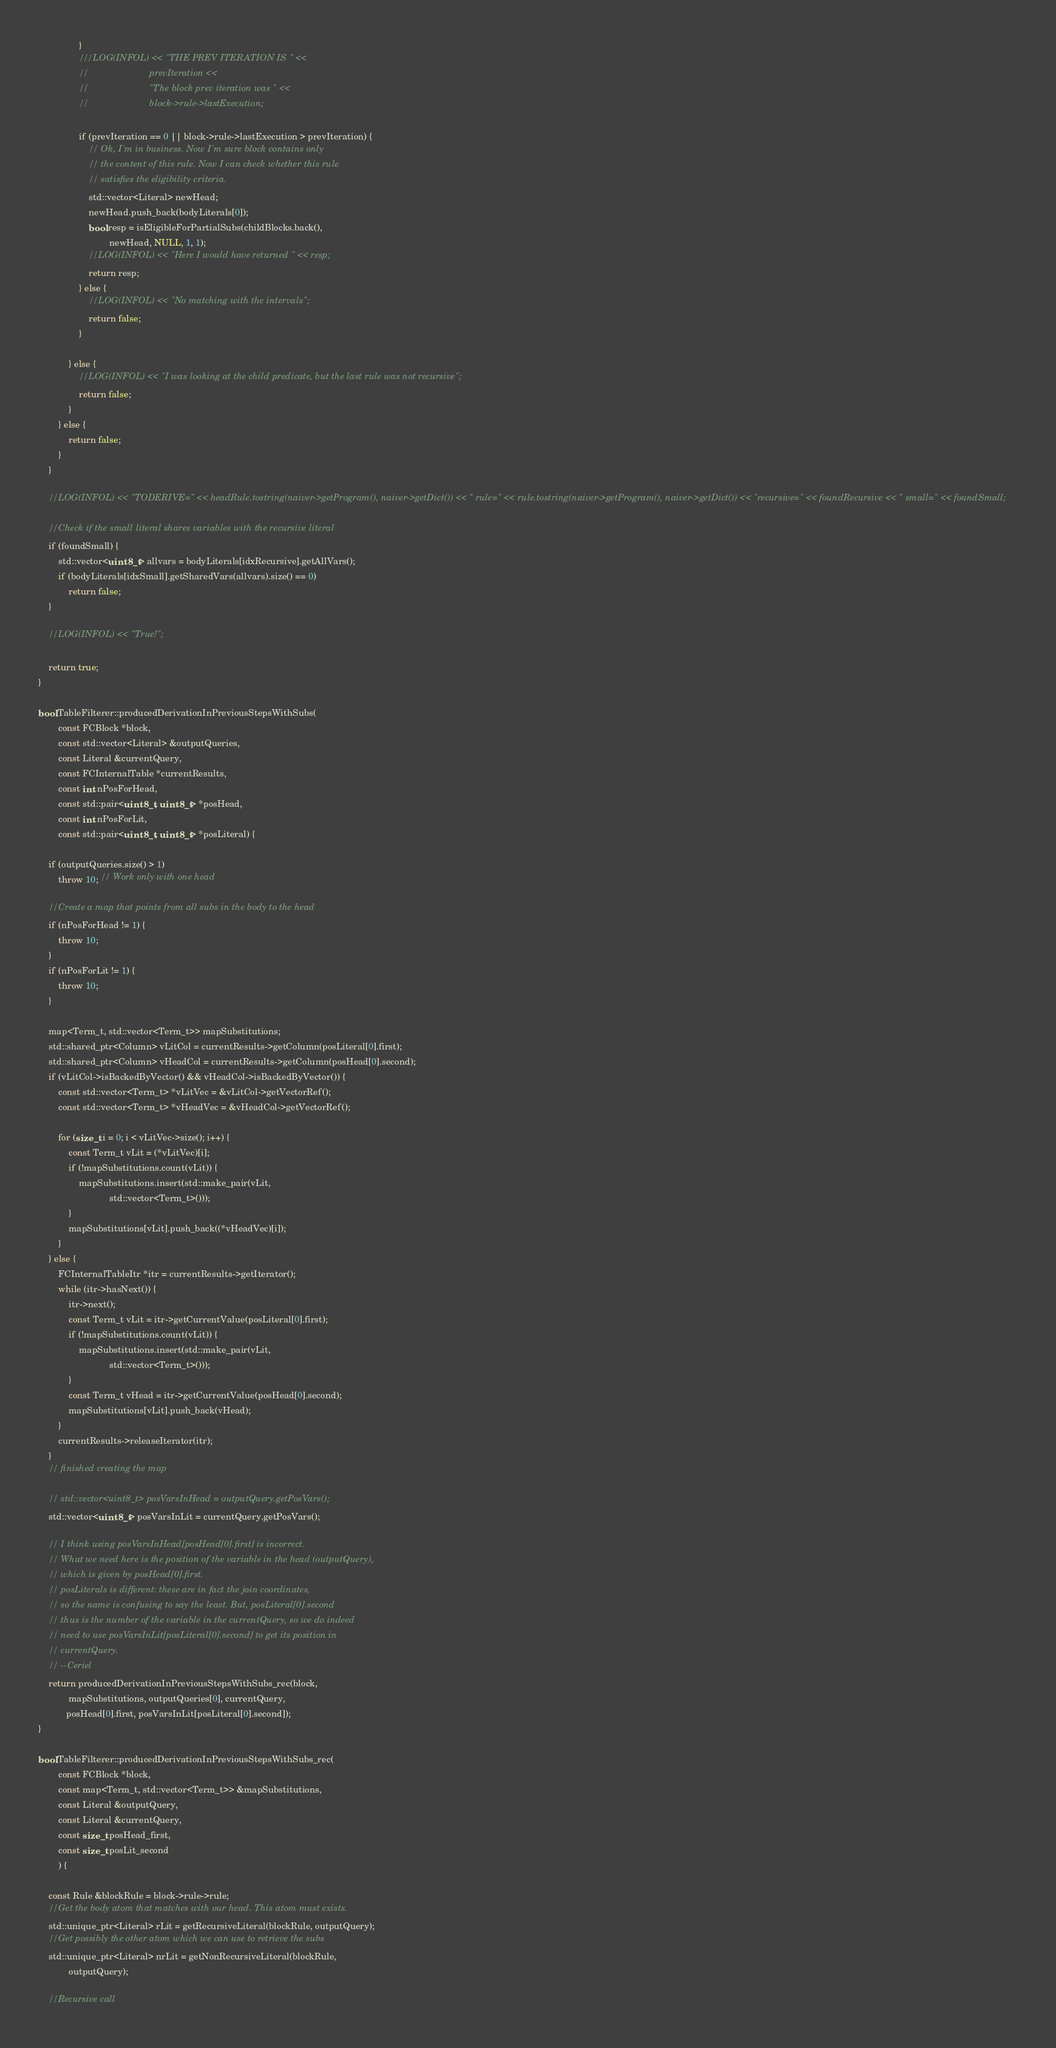<code> <loc_0><loc_0><loc_500><loc_500><_C++_>                }
                ///LOG(INFOL) << "THE PREV ITERATION IS " <<
                //                        prevIteration <<
                //                        "The block prev iteration was " <<
                //                        block->rule->lastExecution;

                if (prevIteration == 0 || block->rule->lastExecution > prevIteration) {
                    // Ok, I'm in business. Now I'm sure block contains only
                    // the content of this rule. Now I can check whether this rule
                    // satisfies the eligibility criteria.
                    std::vector<Literal> newHead;
                    newHead.push_back(bodyLiterals[0]);
                    bool resp = isEligibleForPartialSubs(childBlocks.back(),
                            newHead, NULL, 1, 1);
                    //LOG(INFOL) << "Here I would have returned " << resp;
                    return resp;
                } else {
                    //LOG(INFOL) << "No matching with the intervals";
                    return false;
                }

            } else {
                //LOG(INFOL) << "I was looking at the child predicate, but the last rule was not recursive";
                return false;
            }
        } else {
            return false;
        }
    }

    //LOG(INFOL) << "TODERIVE=" << headRule.tostring(naiver->getProgram(), naiver->getDict()) << " rule=" << rule.tostring(naiver->getProgram(), naiver->getDict()) << "recursive=" << foundRecursive << " small=" << foundSmall;

    //Check if the small literal shares variables with the recursive literal
    if (foundSmall) {
        std::vector<uint8_t> allvars = bodyLiterals[idxRecursive].getAllVars();
        if (bodyLiterals[idxSmall].getSharedVars(allvars).size() == 0)
            return false;
    }

    //LOG(INFOL) << "True!";

    return true;
}

bool TableFilterer::producedDerivationInPreviousStepsWithSubs(
        const FCBlock *block,
        const std::vector<Literal> &outputQueries,
        const Literal &currentQuery,
        const FCInternalTable *currentResults,
        const int nPosForHead,
        const std::pair<uint8_t, uint8_t> *posHead,
        const int nPosForLit,
        const std::pair<uint8_t, uint8_t> *posLiteral) {

    if (outputQueries.size() > 1)
        throw 10; // Work only with one head

    //Create a map that points from all subs in the body to the head
    if (nPosForHead != 1) {
        throw 10;
    }
    if (nPosForLit != 1) {
        throw 10;
    }

    map<Term_t, std::vector<Term_t>> mapSubstitutions;
    std::shared_ptr<Column> vLitCol = currentResults->getColumn(posLiteral[0].first);
    std::shared_ptr<Column> vHeadCol = currentResults->getColumn(posHead[0].second);
    if (vLitCol->isBackedByVector() && vHeadCol->isBackedByVector()) {
        const std::vector<Term_t> *vLitVec = &vLitCol->getVectorRef();
        const std::vector<Term_t> *vHeadVec = &vHeadCol->getVectorRef();

        for (size_t i = 0; i < vLitVec->size(); i++) {
            const Term_t vLit = (*vLitVec)[i];
            if (!mapSubstitutions.count(vLit)) {
                mapSubstitutions.insert(std::make_pair(vLit,
                            std::vector<Term_t>()));
            }
            mapSubstitutions[vLit].push_back((*vHeadVec)[i]);
        }
    } else {
        FCInternalTableItr *itr = currentResults->getIterator();
        while (itr->hasNext()) {
            itr->next();
            const Term_t vLit = itr->getCurrentValue(posLiteral[0].first);
            if (!mapSubstitutions.count(vLit)) {
                mapSubstitutions.insert(std::make_pair(vLit,
                            std::vector<Term_t>()));
            }
            const Term_t vHead = itr->getCurrentValue(posHead[0].second);
            mapSubstitutions[vLit].push_back(vHead);
        }
        currentResults->releaseIterator(itr);
    }
    // finished creating the map

    // std::vector<uint8_t> posVarsInHead = outputQuery.getPosVars();
    std::vector<uint8_t> posVarsInLit = currentQuery.getPosVars();

    // I think using posVarsInHead[posHead[0].first] is incorrect.
    // What we need here is the position of the variable in the head (outputQuery),
    // which is given by posHead[0].first.
    // posLiterals is different: these are in fact the join coordinates,
    // so the name is confusing to say the least. But, posLiteral[0].second
    // thus is the number of the variable in the currentQuery, so we do indeed
    // need to use posVarsInLit[posLiteral[0].second] to get its position in
    // currentQuery.
    // --Ceriel
    return producedDerivationInPreviousStepsWithSubs_rec(block,
            mapSubstitutions, outputQueries[0], currentQuery,
           posHead[0].first, posVarsInLit[posLiteral[0].second]);
}

bool TableFilterer::producedDerivationInPreviousStepsWithSubs_rec(
        const FCBlock *block,
        const map<Term_t, std::vector<Term_t>> &mapSubstitutions,
        const Literal &outputQuery,
        const Literal &currentQuery,
        const size_t posHead_first,
        const size_t posLit_second
        ) {

    const Rule &blockRule = block->rule->rule;
    //Get the body atom that matches with our head. This atom must exists.
    std::unique_ptr<Literal> rLit = getRecursiveLiteral(blockRule, outputQuery);
    //Get possibly the other atom which we can use to retrieve the subs
    std::unique_ptr<Literal> nrLit = getNonRecursiveLiteral(blockRule,
            outputQuery);

    //Recursive call</code> 